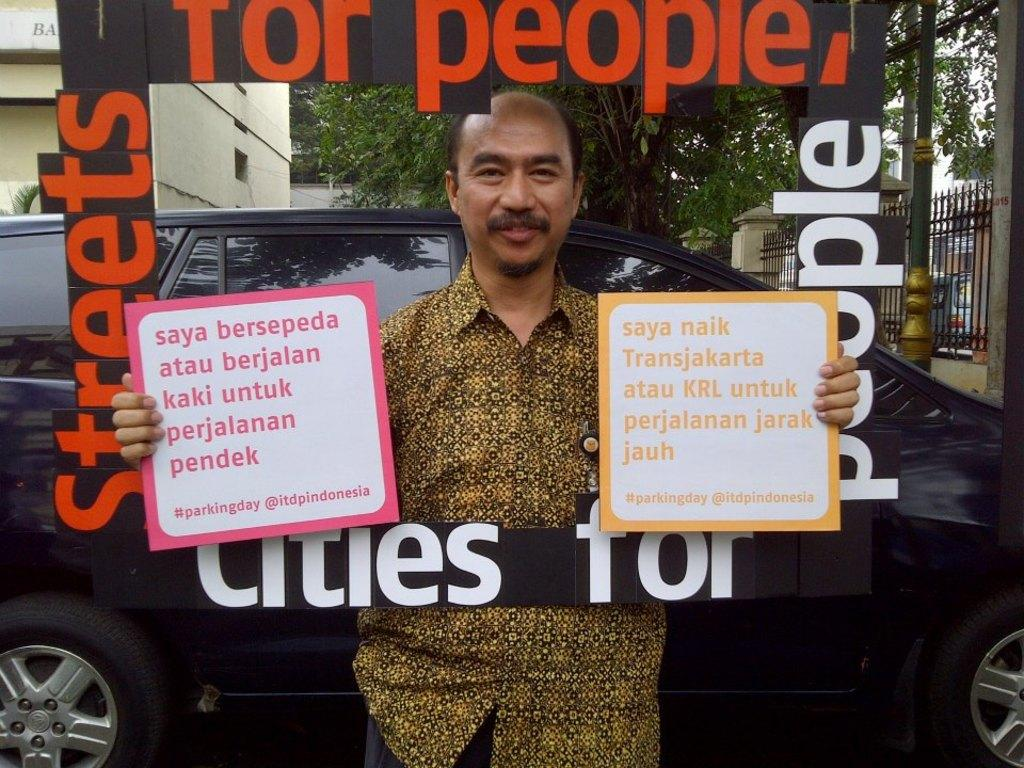What is the main subject in the center of the image? There is a person standing with boards in the center of the image. What can be seen in the background of the image? There is a car, trees, a vehicle, and fencing in the background of the image. What type of watch is the person wearing in the image? There is no watch visible on the person in the image. What kind of suit is the person wearing in the image? There is no suit visible on the person in the image. 